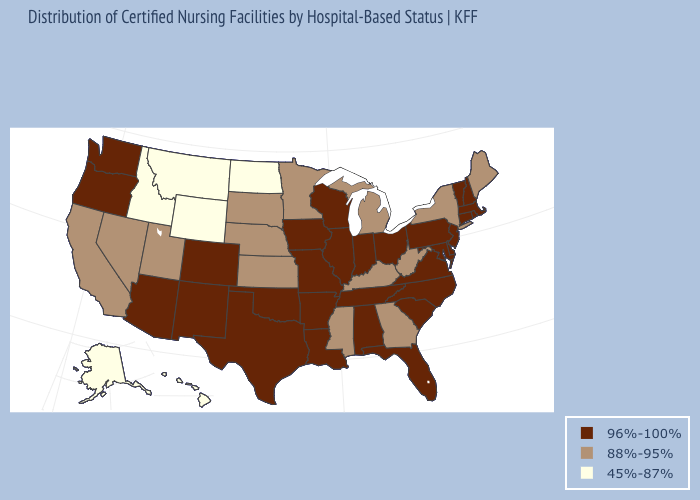Among the states that border New Hampshire , does Massachusetts have the highest value?
Give a very brief answer. Yes. What is the value of Wyoming?
Keep it brief. 45%-87%. What is the lowest value in states that border New Jersey?
Give a very brief answer. 88%-95%. What is the highest value in states that border West Virginia?
Write a very short answer. 96%-100%. Which states have the lowest value in the USA?
Quick response, please. Alaska, Hawaii, Idaho, Montana, North Dakota, Wyoming. Does the first symbol in the legend represent the smallest category?
Answer briefly. No. Name the states that have a value in the range 45%-87%?
Answer briefly. Alaska, Hawaii, Idaho, Montana, North Dakota, Wyoming. Does Nevada have the same value as Hawaii?
Answer briefly. No. Does Alabama have a higher value than Montana?
Keep it brief. Yes. Does Pennsylvania have the same value as Massachusetts?
Be succinct. Yes. Does South Carolina have a lower value than Maryland?
Quick response, please. No. What is the highest value in the USA?
Quick response, please. 96%-100%. What is the highest value in the USA?
Short answer required. 96%-100%. Among the states that border Maryland , which have the highest value?
Answer briefly. Delaware, Pennsylvania, Virginia. 